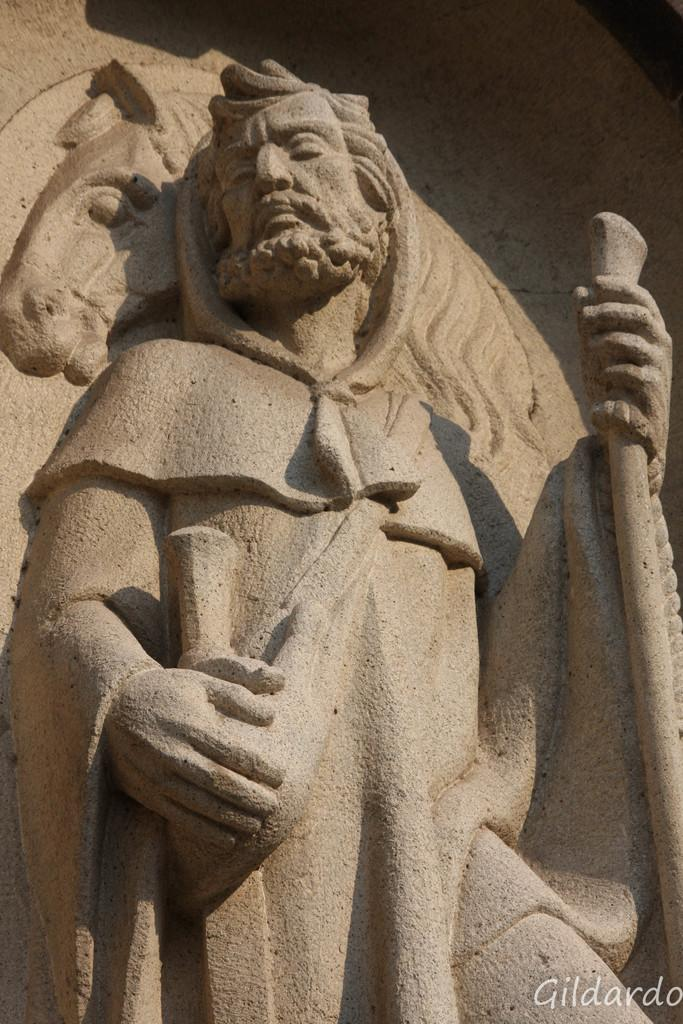What is the main subject in the image? There is a sculpture in the image. Is there any text associated with the sculpture? Yes, there is a text in the bottom right of the image. What type of sofa is visible in the image? There is no sofa present in the image. What request is being made by the sculpture in the image? The sculpture is an inanimate object and cannot make requests. 